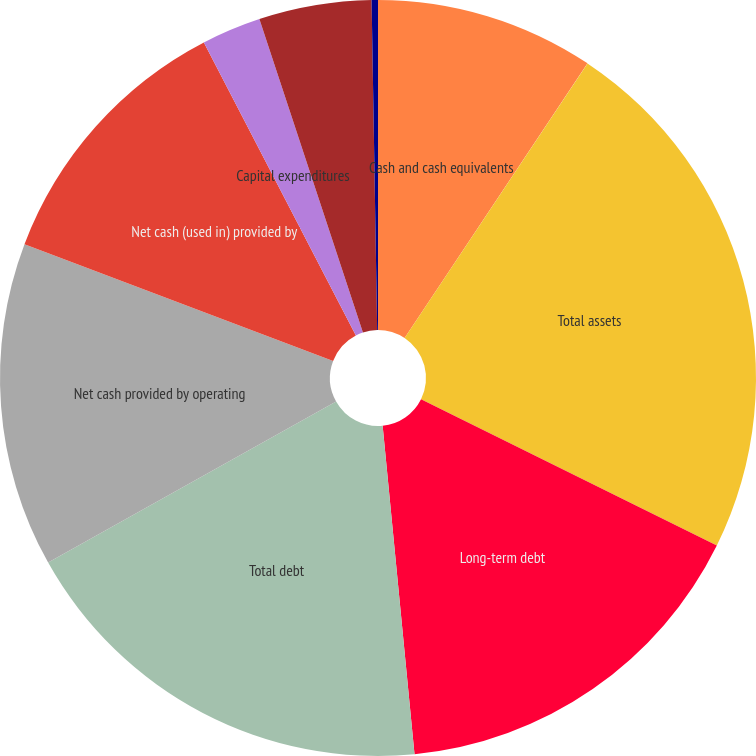<chart> <loc_0><loc_0><loc_500><loc_500><pie_chart><fcel>Cash and cash equivalents<fcel>Total assets<fcel>Long-term debt<fcel>Total debt<fcel>Net cash provided by operating<fcel>Net cash (used in) provided by<fcel>Capital expenditures<fcel>Purchases of treasury stock<fcel>Dividends paid<nl><fcel>9.35%<fcel>22.96%<fcel>16.15%<fcel>18.42%<fcel>13.88%<fcel>11.62%<fcel>2.54%<fcel>4.81%<fcel>0.27%<nl></chart> 